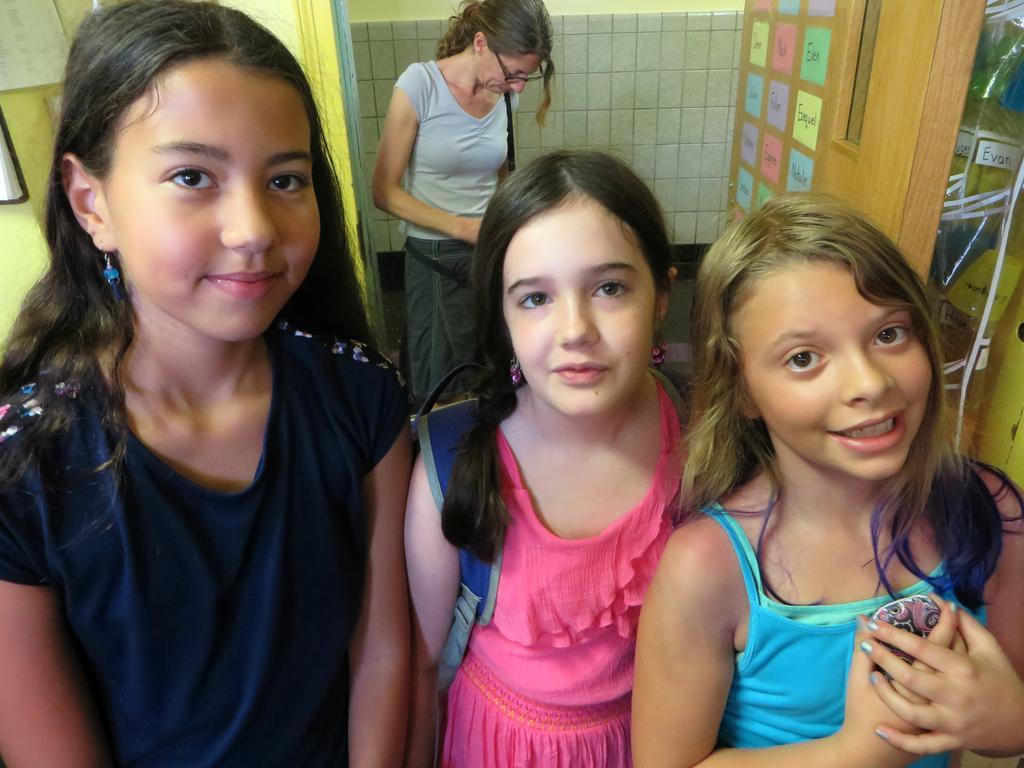How would you summarize this image in a sentence or two? In this image I can see four people standing and wearing different color dress. Back I can see white wall and colorful paper are attached to wooden wall. 